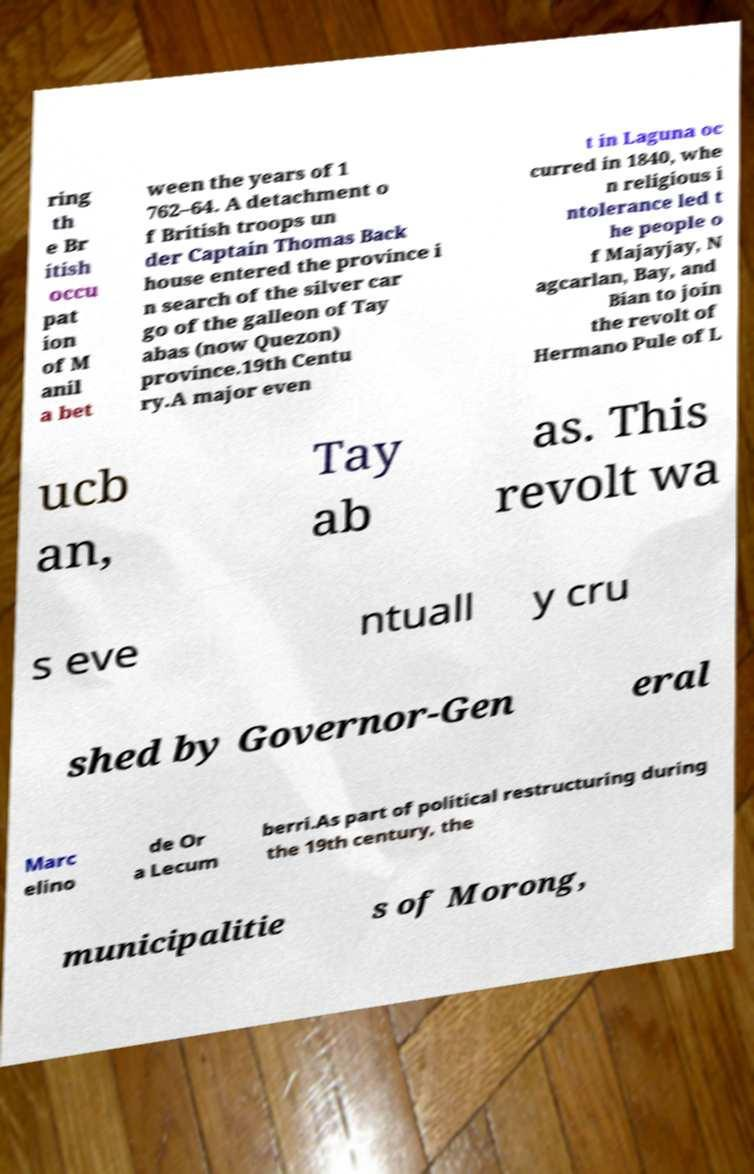Can you accurately transcribe the text from the provided image for me? ring th e Br itish occu pat ion of M anil a bet ween the years of 1 762–64. A detachment o f British troops un der Captain Thomas Back house entered the province i n search of the silver car go of the galleon of Tay abas (now Quezon) province.19th Centu ry.A major even t in Laguna oc curred in 1840, whe n religious i ntolerance led t he people o f Majayjay, N agcarlan, Bay, and Bian to join the revolt of Hermano Pule of L ucb an, Tay ab as. This revolt wa s eve ntuall y cru shed by Governor-Gen eral Marc elino de Or a Lecum berri.As part of political restructuring during the 19th century, the municipalitie s of Morong, 